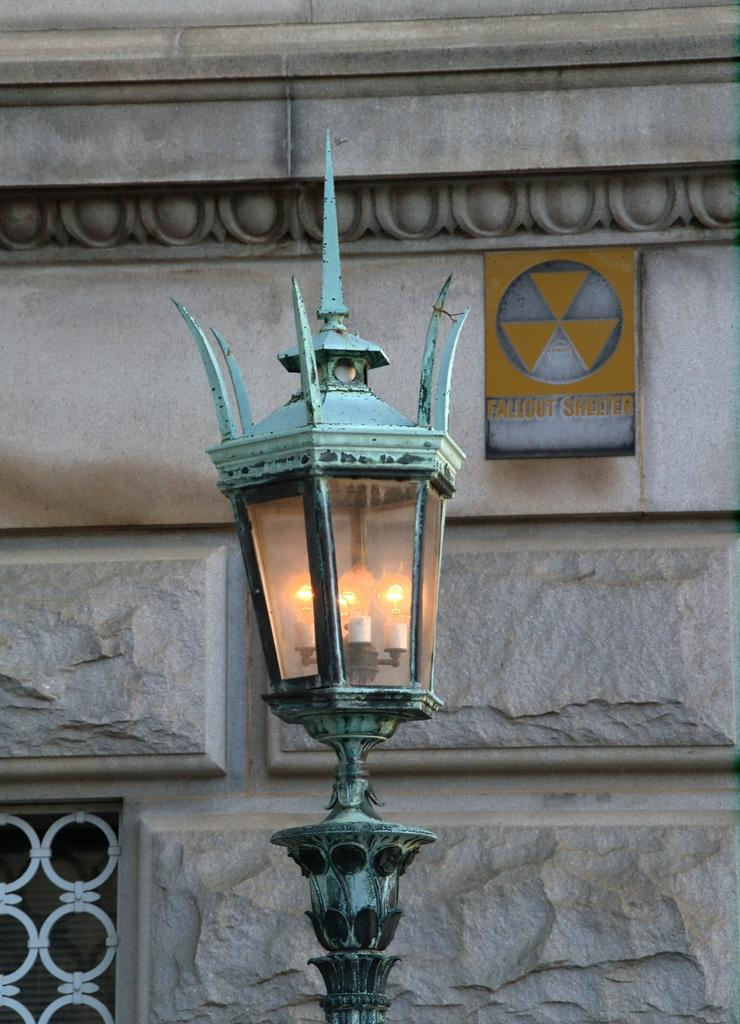What is the color of the lamp post in the image? The lamp post in the image is green. Where is the lamp post located in the image? The lamp post is in the front of the image. What type of wall is visible in the image? There is a granite wall in the image. How is the granite wall positioned in relation to the lamp post? The granite wall is behind the lamp post. What is the color of the window grill in the image? The window grill in the image is white. What type of thrill can be seen in the image? There is no thrill present in the image; it features a green lamp post, a granite wall, and a white window grill. What musical instrument is being played in the image? There is no musical instrument being played in the image. 